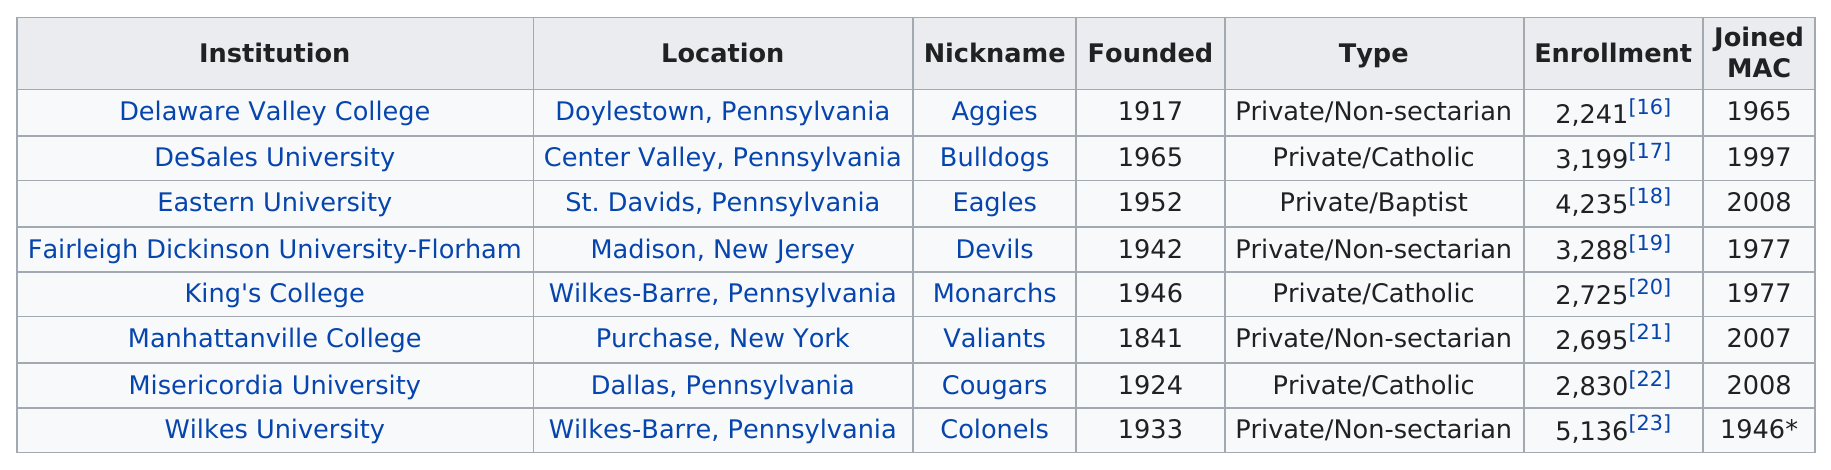Indicate a few pertinent items in this graphic. The enrollment number of Misericordia University is 2,830. According to the data provided, 8,754 students are currently enrolled in private or Catholic schools. Delaware Valley College is a private, non-sectarian institution of higher education that was founded in 1917. After 2000, an unknown number of teams joined the MAC conference. Eastern University is a private institution that is affiliated with the Baptist denomination. 